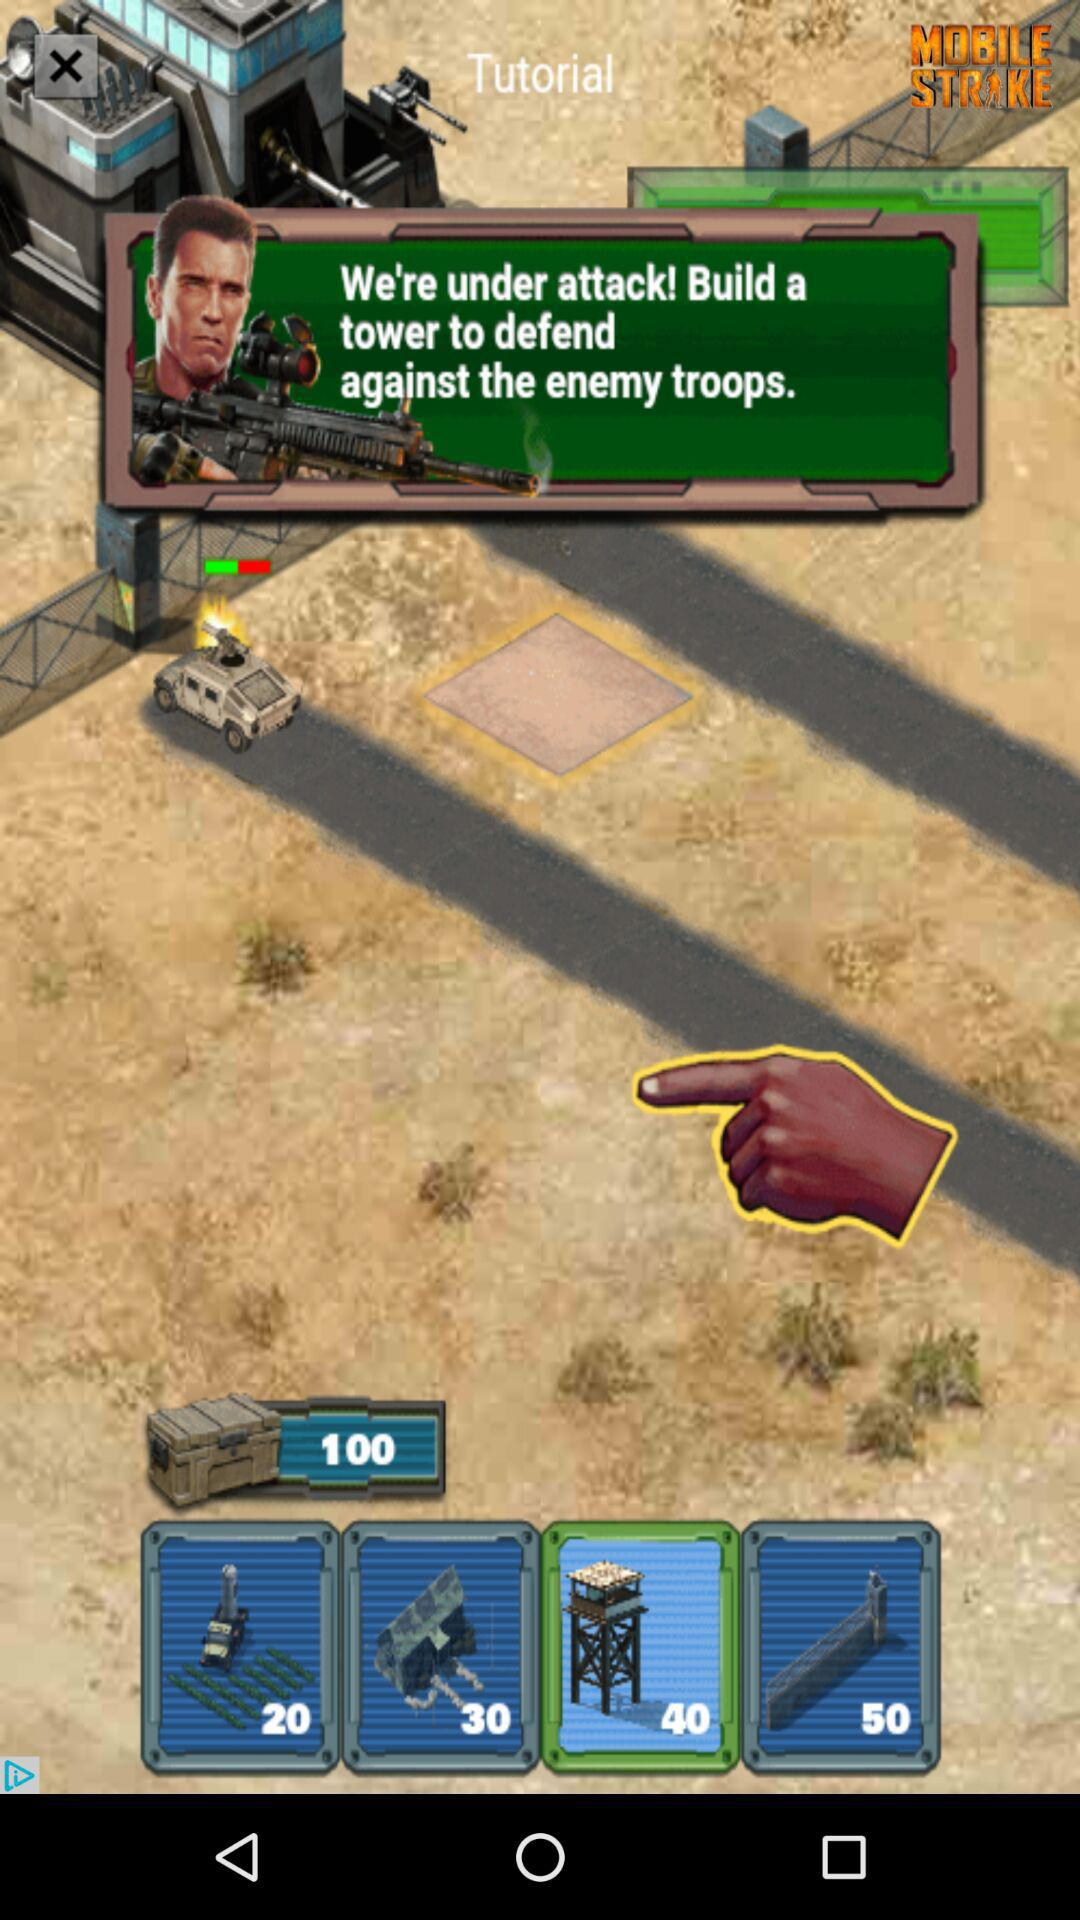How much more does the cost of the 50 unit tower cost than the 20 unit tower?
Answer the question using a single word or phrase. 30 